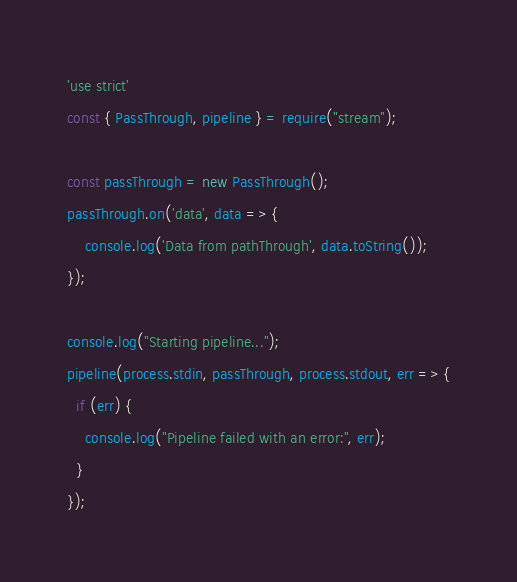Convert code to text. <code><loc_0><loc_0><loc_500><loc_500><_JavaScript_>'use strict'
const { PassThrough, pipeline } = require("stream");

const passThrough = new PassThrough();
passThrough.on('data', data => {
    console.log('Data from pathThrough', data.toString());
});

console.log("Starting pipeline...");
pipeline(process.stdin, passThrough, process.stdout, err => {
  if (err) {
    console.log("Pipeline failed with an error:", err);
  }
});
</code> 